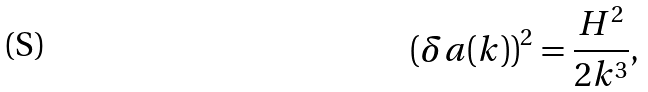Convert formula to latex. <formula><loc_0><loc_0><loc_500><loc_500>( \delta a ( k ) ) ^ { 2 } = \frac { H ^ { 2 } } { 2 k ^ { 3 } } ,</formula> 